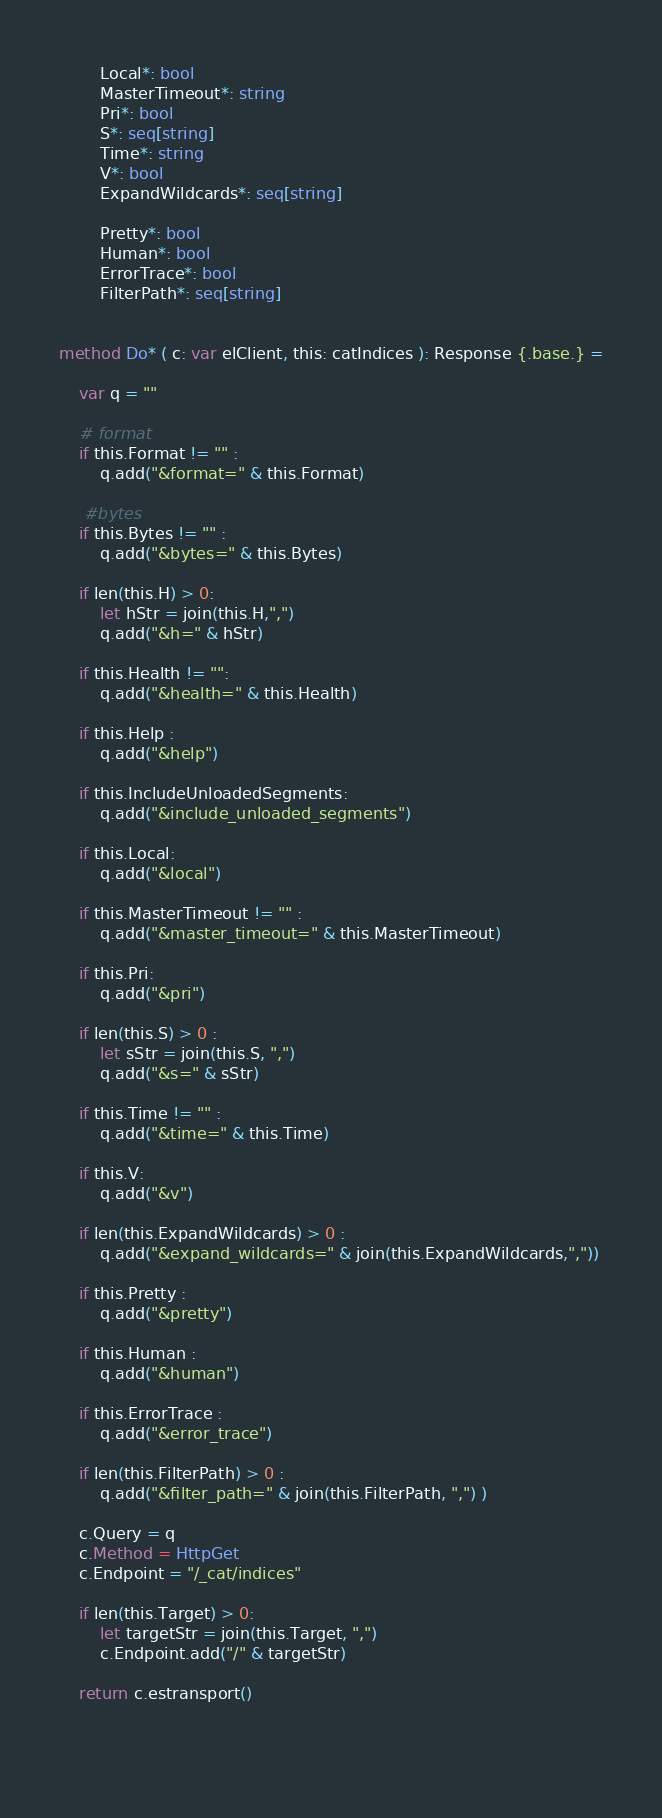<code> <loc_0><loc_0><loc_500><loc_500><_Nim_>        Local*: bool
        MasterTimeout*: string
        Pri*: bool
        S*: seq[string]
        Time*: string
        V*: bool
        ExpandWildcards*: seq[string]

        Pretty*: bool
        Human*: bool
        ErrorTrace*: bool
        FilterPath*: seq[string]


method Do* ( c: var elClient, this: catIndices ): Response {.base.} =

    var q = ""

    # format 
    if this.Format != "" :
        q.add("&format=" & this.Format)
    
     #bytes
    if this.Bytes != "" :
        q.add("&bytes=" & this.Bytes)    

    if len(this.H) > 0:
        let hStr = join(this.H,",")
        q.add("&h=" & hStr)

    if this.Health != "":
        q.add("&health=" & this.Health)

    if this.Help :
        q.add("&help")

    if this.IncludeUnloadedSegments:
        q.add("&include_unloaded_segments")

    if this.Local:
        q.add("&local")

    if this.MasterTimeout != "" :
        q.add("&master_timeout=" & this.MasterTimeout)

    if this.Pri:
        q.add("&pri")

    if len(this.S) > 0 :
        let sStr = join(this.S, ",")
        q.add("&s=" & sStr)

    if this.Time != "" :
        q.add("&time=" & this.Time)

    if this.V:
        q.add("&v")

    if len(this.ExpandWildcards) > 0 :
        q.add("&expand_wildcards=" & join(this.ExpandWildcards,","))

    if this.Pretty :
        q.add("&pretty")

    if this.Human :
        q.add("&human")

    if this.ErrorTrace :
        q.add("&error_trace") 

    if len(this.FilterPath) > 0 :
        q.add("&filter_path=" & join(this.FilterPath, ",") )

    c.Query = q
    c.Method = HttpGet
    c.Endpoint = "/_cat/indices"

    if len(this.Target) > 0:
        let targetStr = join(this.Target, ",")
        c.Endpoint.add("/" & targetStr)

    return c.estransport()
    

    </code> 